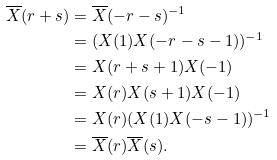Convert formula to latex. <formula><loc_0><loc_0><loc_500><loc_500>\overline { X } ( r + s ) & = \overline { X } ( - r - s ) ^ { - 1 } \\ & = ( X ( 1 ) X ( - r - s - 1 ) ) ^ { - 1 } \\ & = X ( r + s + 1 ) X ( - 1 ) \\ & = X ( r ) X ( s + 1 ) X ( - 1 ) \\ & = X ( r ) ( X ( 1 ) X ( - s - 1 ) ) ^ { - 1 } \\ & = \overline { X } ( r ) \overline { X } ( s ) .</formula> 